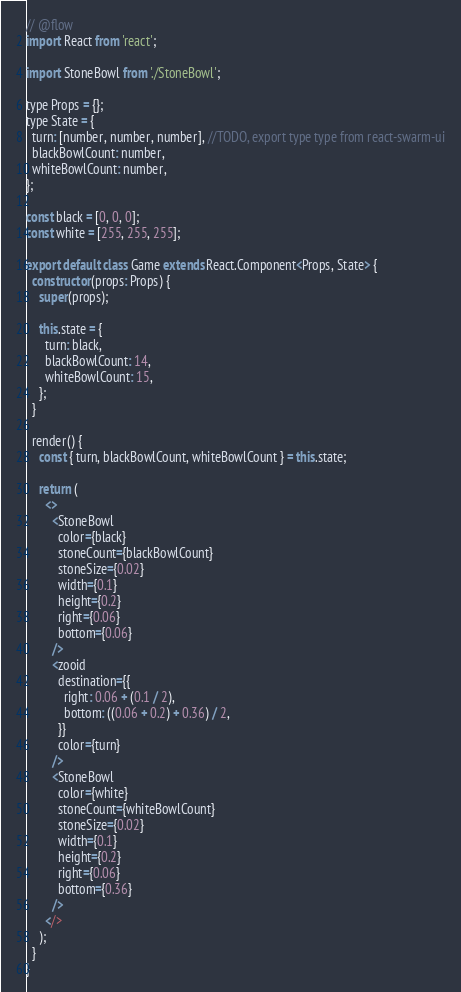Convert code to text. <code><loc_0><loc_0><loc_500><loc_500><_JavaScript_>// @flow
import React from 'react';

import StoneBowl from './StoneBowl';

type Props = {};
type State = {
  turn: [number, number, number], //TODO, export type type from react-swarm-ui
  blackBowlCount: number,
  whiteBowlCount: number,
};

const black = [0, 0, 0];
const white = [255, 255, 255];

export default class Game extends React.Component<Props, State> {
  constructor(props: Props) {
    super(props);

    this.state = {
      turn: black,
      blackBowlCount: 14,
      whiteBowlCount: 15,
    };
  }

  render() {
    const { turn, blackBowlCount, whiteBowlCount } = this.state;

    return (
      <>
        <StoneBowl
          color={black}
          stoneCount={blackBowlCount}
          stoneSize={0.02}
          width={0.1}
          height={0.2}
          right={0.06}
          bottom={0.06}
        />
        <zooid
          destination={{
            right: 0.06 + (0.1 / 2),
            bottom: ((0.06 + 0.2) + 0.36) / 2,
          }}
          color={turn}
        />
        <StoneBowl
          color={white}
          stoneCount={whiteBowlCount}
          stoneSize={0.02}
          width={0.1}
          height={0.2}
          right={0.06}
          bottom={0.36}
        />
      </>
    );
  }
}
</code> 